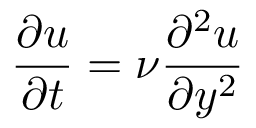Convert formula to latex. <formula><loc_0><loc_0><loc_500><loc_500>{ \frac { \partial u } { \partial t } } = \nu { \frac { \partial ^ { 2 } u } { \partial y ^ { 2 } } }</formula> 